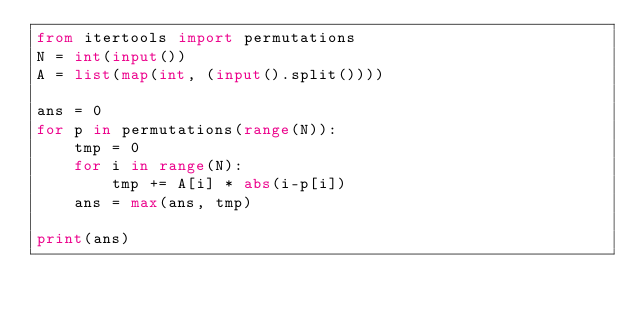<code> <loc_0><loc_0><loc_500><loc_500><_Python_>from itertools import permutations
N = int(input())
A = list(map(int, (input().split())))

ans = 0
for p in permutations(range(N)):
    tmp = 0
    for i in range(N):
        tmp += A[i] * abs(i-p[i])
    ans = max(ans, tmp)

print(ans)
</code> 